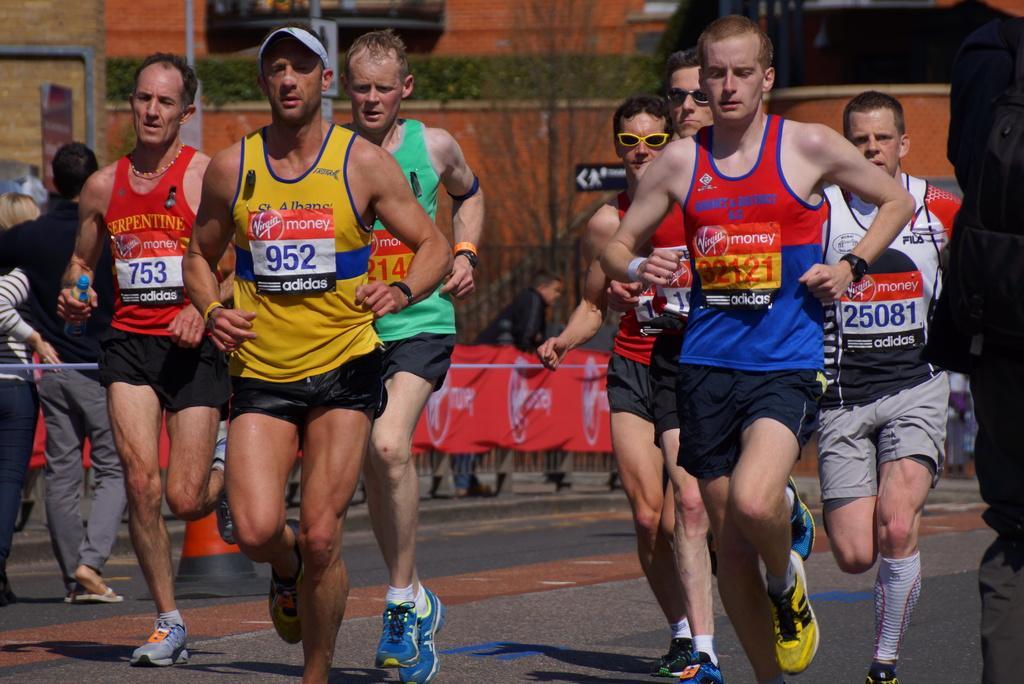Please provide a concise description of this image. In this picture we can see a group of men running on the road and in the background we can see banner, trees, pipes and some persons standing at fence. 